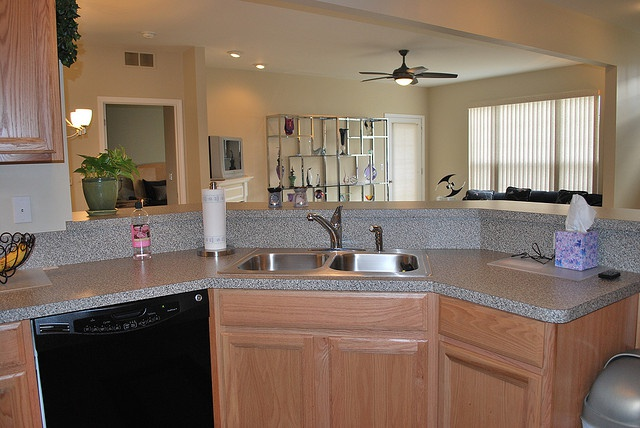Describe the objects in this image and their specific colors. I can see sink in brown, gray, lightgray, and darkgray tones, potted plant in brown, darkgreen, black, and gray tones, couch in brown, black, gray, darkgray, and lightgray tones, bottle in brown, gray, and darkgray tones, and banana in brown, olive, black, orange, and maroon tones in this image. 